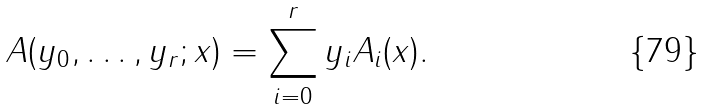<formula> <loc_0><loc_0><loc_500><loc_500>A ( y _ { 0 } , \dots , y _ { r } ; x ) = \sum _ { i = 0 } ^ { r } y _ { i } A _ { i } ( x ) .</formula> 